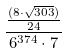Convert formula to latex. <formula><loc_0><loc_0><loc_500><loc_500>\frac { \frac { ( 8 \cdot \sqrt { 3 0 3 } ) } { 2 4 } } { 6 ^ { 3 7 4 } \cdot 7 }</formula> 